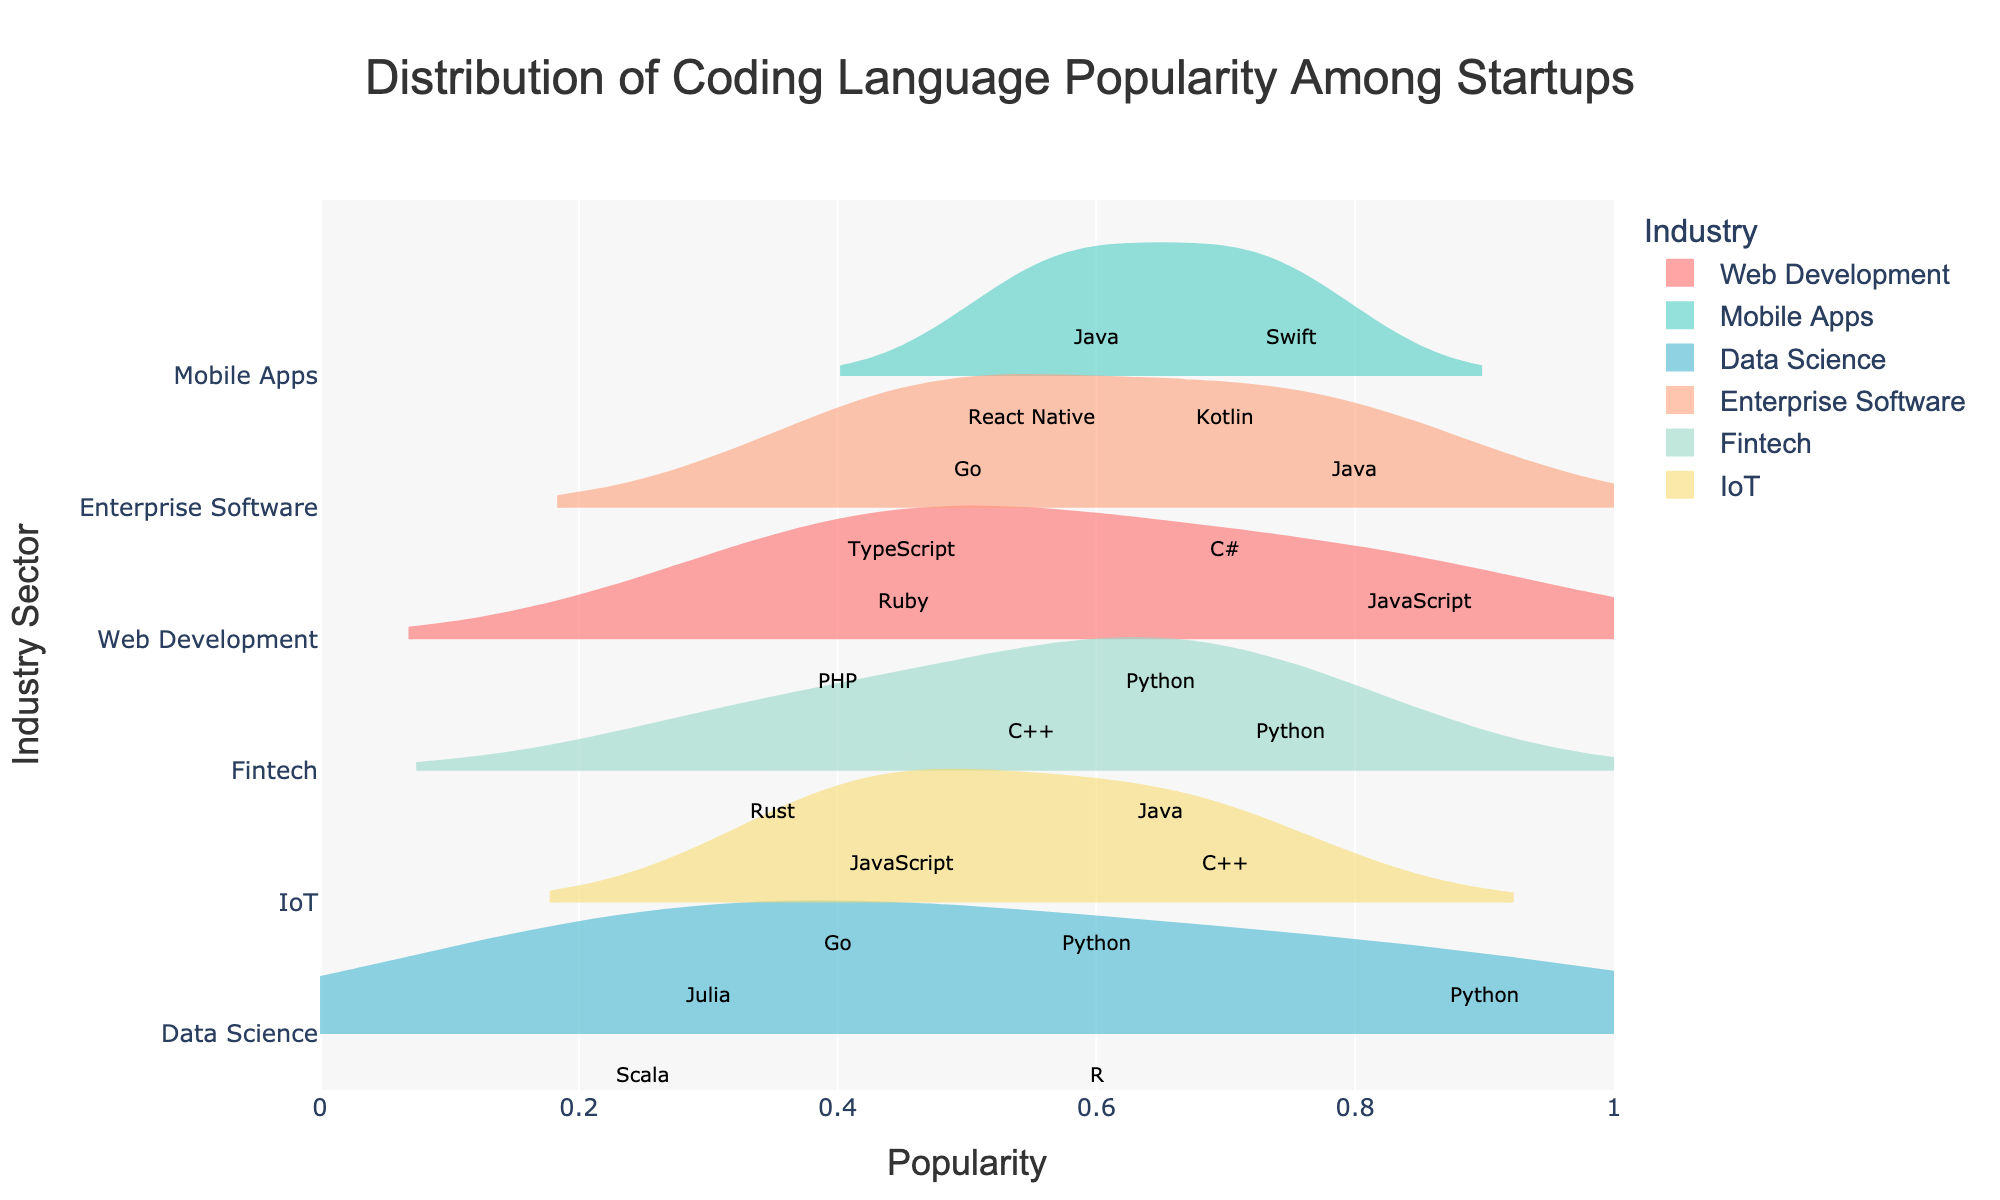What is the title of the figure? The title of the figure appears at the top center and reads "Distribution of Coding Language Popularity Among Startups".
Answer: Distribution of Coding Language Popularity Among Startups Which industry has the highest popularity for Python? By checking each industry's Python popularity, Data Science has the highest value at 0.90.
Answer: Data Science How does the popularity of JavaScript in Web Development compare to IoT? In Web Development, JavaScript's popularity is 0.85, while in IoT, it is 0.45. So, JavaScript is more popular in Web Development.
Answer: JavaScript is more popular in Web Development Which language in Fintech has the lowest popularity? C++ and Rust are both shown, with Rust having a popularity of 0.35, lower than C++.
Answer: Rust What is the total number of industries displayed in the figure? The y-axis lists each industry, resulting in a total of 5 industries being displayed: Web Development, Mobile Apps, Data Science, Enterprise Software, and Fintech.
Answer: 5 Compare the popularity of C++ in Fintech and IoT. Which is higher? The popularity of C++ in Fintech is 0.55, while in IoT, it is 0.70. Therefore, C++ is more popular in IoT.
Answer: IoT What is the average popularity of all Java languages across all industries? Java appears in several industries with popularity rates of 0.60 (Mobile Apps), 0.80 (Enterprise Software), 0.65 (Fintech), and 0.60 (IoT). The average is calculated as (0.60 + 0.80 + 0.65 + 0.60) / 4 = 0.66.
Answer: 0.66 Which industry has the most languages with popularity above 0.70? By inspecting which industries have languages above 0.70, Mobile Apps has the most with two languages: Swift (0.75) and Kotlin (0.70).
Answer: Mobile Apps Is there a language that is popular in all industries? By checking each language across all industries, Python and Java appear in multiple industries but not all of them. No language is consistently present in every industry.
Answer: No What is the highest popularity value in any industry sector? By examining the popularity values, the highest value observed is Python's 0.90 in Data Science.
Answer: 0.90 